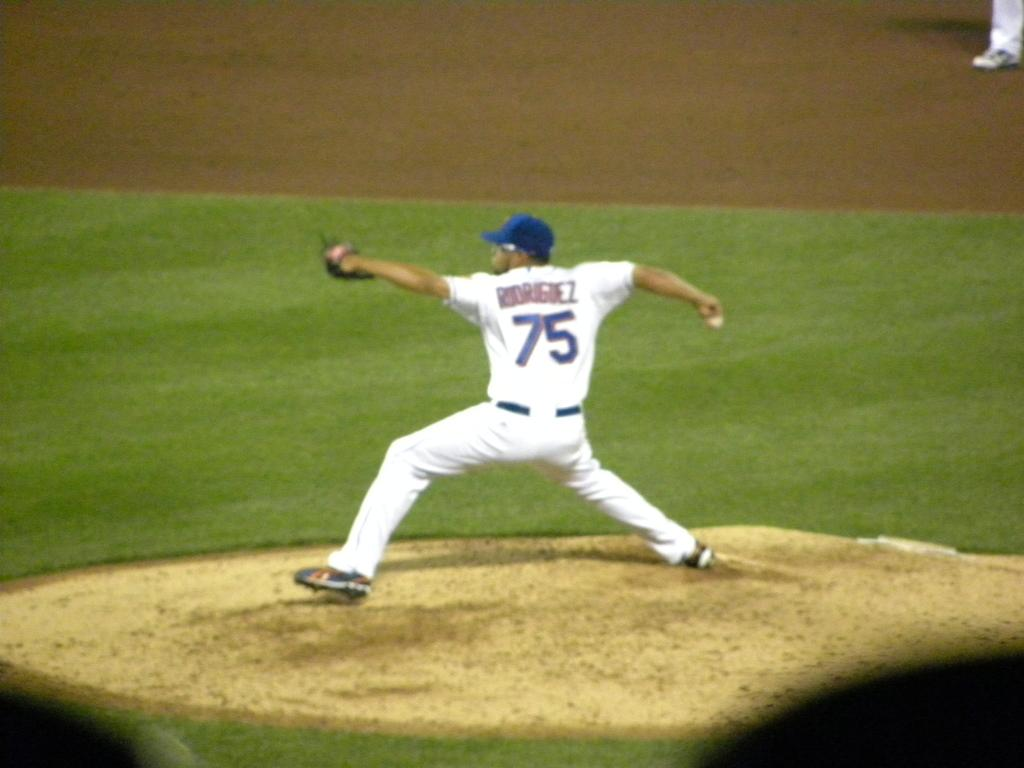<image>
Present a compact description of the photo's key features. a player that has the number 75 on their back 